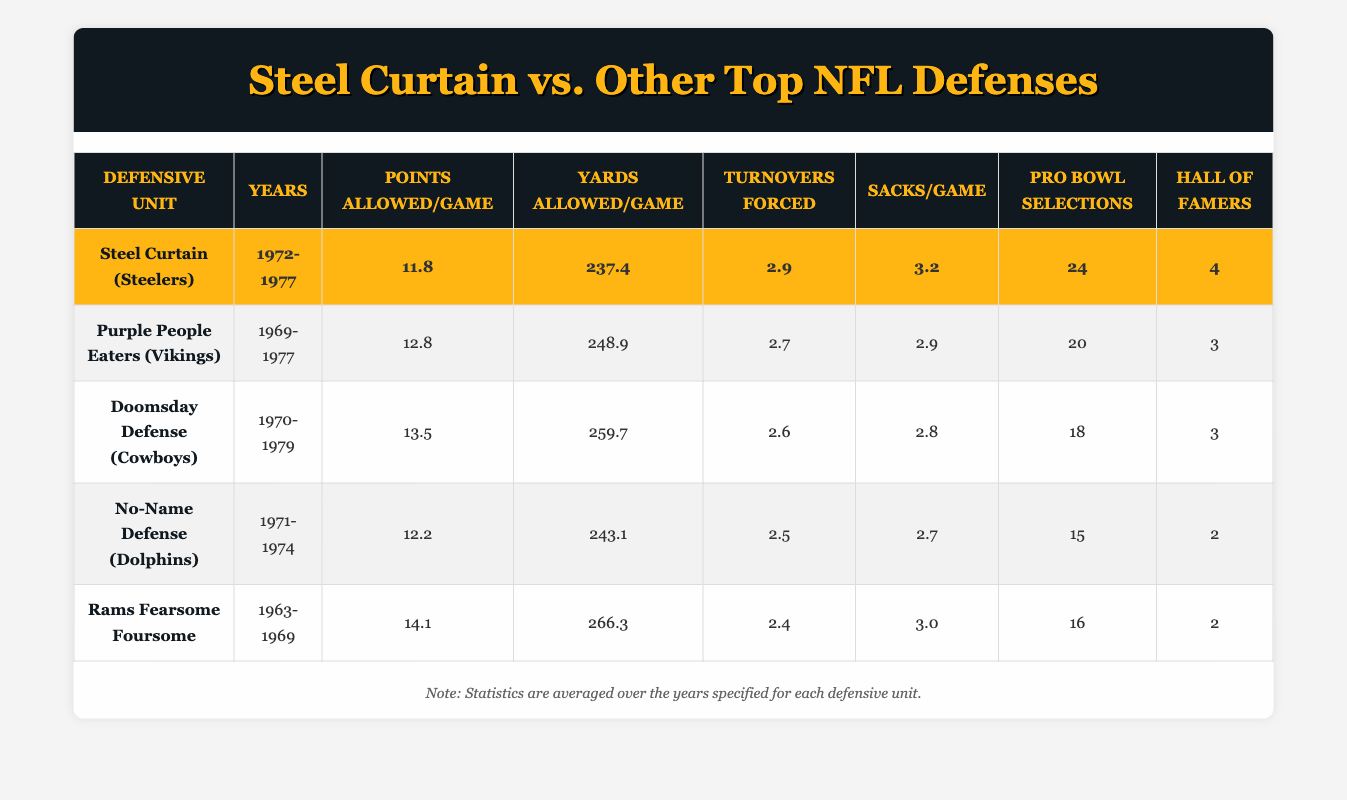What is the average points allowed per game by the Steel Curtain? The Steel Curtain has a points allowed per game statistic of 11.8, which is directly provided in the table. Therefore, the average points allowed by them is simply 11.8.
Answer: 11.8 Which defense allowed the fewest yards per game? The Steel Curtain allows 237.4 yards per game, which is less than any other listed teams. The next closest, Purple People Eaters, allowed 248.9 yards per game. Thus, the fewest yards allowed per game is by the Steel Curtain.
Answer: Steel Curtain How many more Pro Bowl selections did the Steel Curtain have compared to the Rams Fearsome Foursome? The Steel Curtain earned 24 Pro Bowl selections while the Rams Fearsome Foursome had 16 selections. The difference is calculated as 24 - 16 = 8, showing that the Steel Curtain had 8 more selections.
Answer: 8 Is it true that the No-Name Defense had a better average sacks per game than the Doomsday Defense? The No-Name Defense had an average of 2.7 sacks per game while the Doomsday Defense had 2.8 sacks per game. Given that 2.7 is less than 2.8, this statement is false.
Answer: False What is the range of points allowed per game among all the defenses listed? The highest points allowed per game comes from the Rams Fearsome Foursome at 14.1, and the lowest is from the Steel Curtain at 11.8. To find the range, we subtract the lowest from the highest: 14.1 - 11.8 = 2.3. Thus, the range is 2.3 points.
Answer: 2.3 Which team forced the most turnovers on average? The Steel Curtain forced 2.9 turnovers per game, which is more than any other unit listed. For instance, the Purple People Eaters had 2.7. Therefore, the team that forced the most turnovers on average is the Steel Curtain.
Answer: Steel Curtain What is the average number of Hall of Famers in the listed defenses? To find the average number of Hall of Famers, we add the Hall of Famers for each team: 4 (Steel Curtain) + 3 (Purple People Eaters) + 3 (Doomsday Defense) + 2 (No-Name Defense) + 2 (Rams Fearsome Foursome) = 14. There are 5 teams, so the average is 14/5 = 2.8.
Answer: 2.8 Did the Purple People Eaters have a better average in yards allowed per game than the No-Name Defense? The Purple People Eaters allowed 248.9 yards per game, while the No-Name Defense allowed 243.1 yards per game. Since 248.9 is greater than 243.1, this statement is false.
Answer: False 